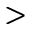Convert formula to latex. <formula><loc_0><loc_0><loc_500><loc_500>></formula> 